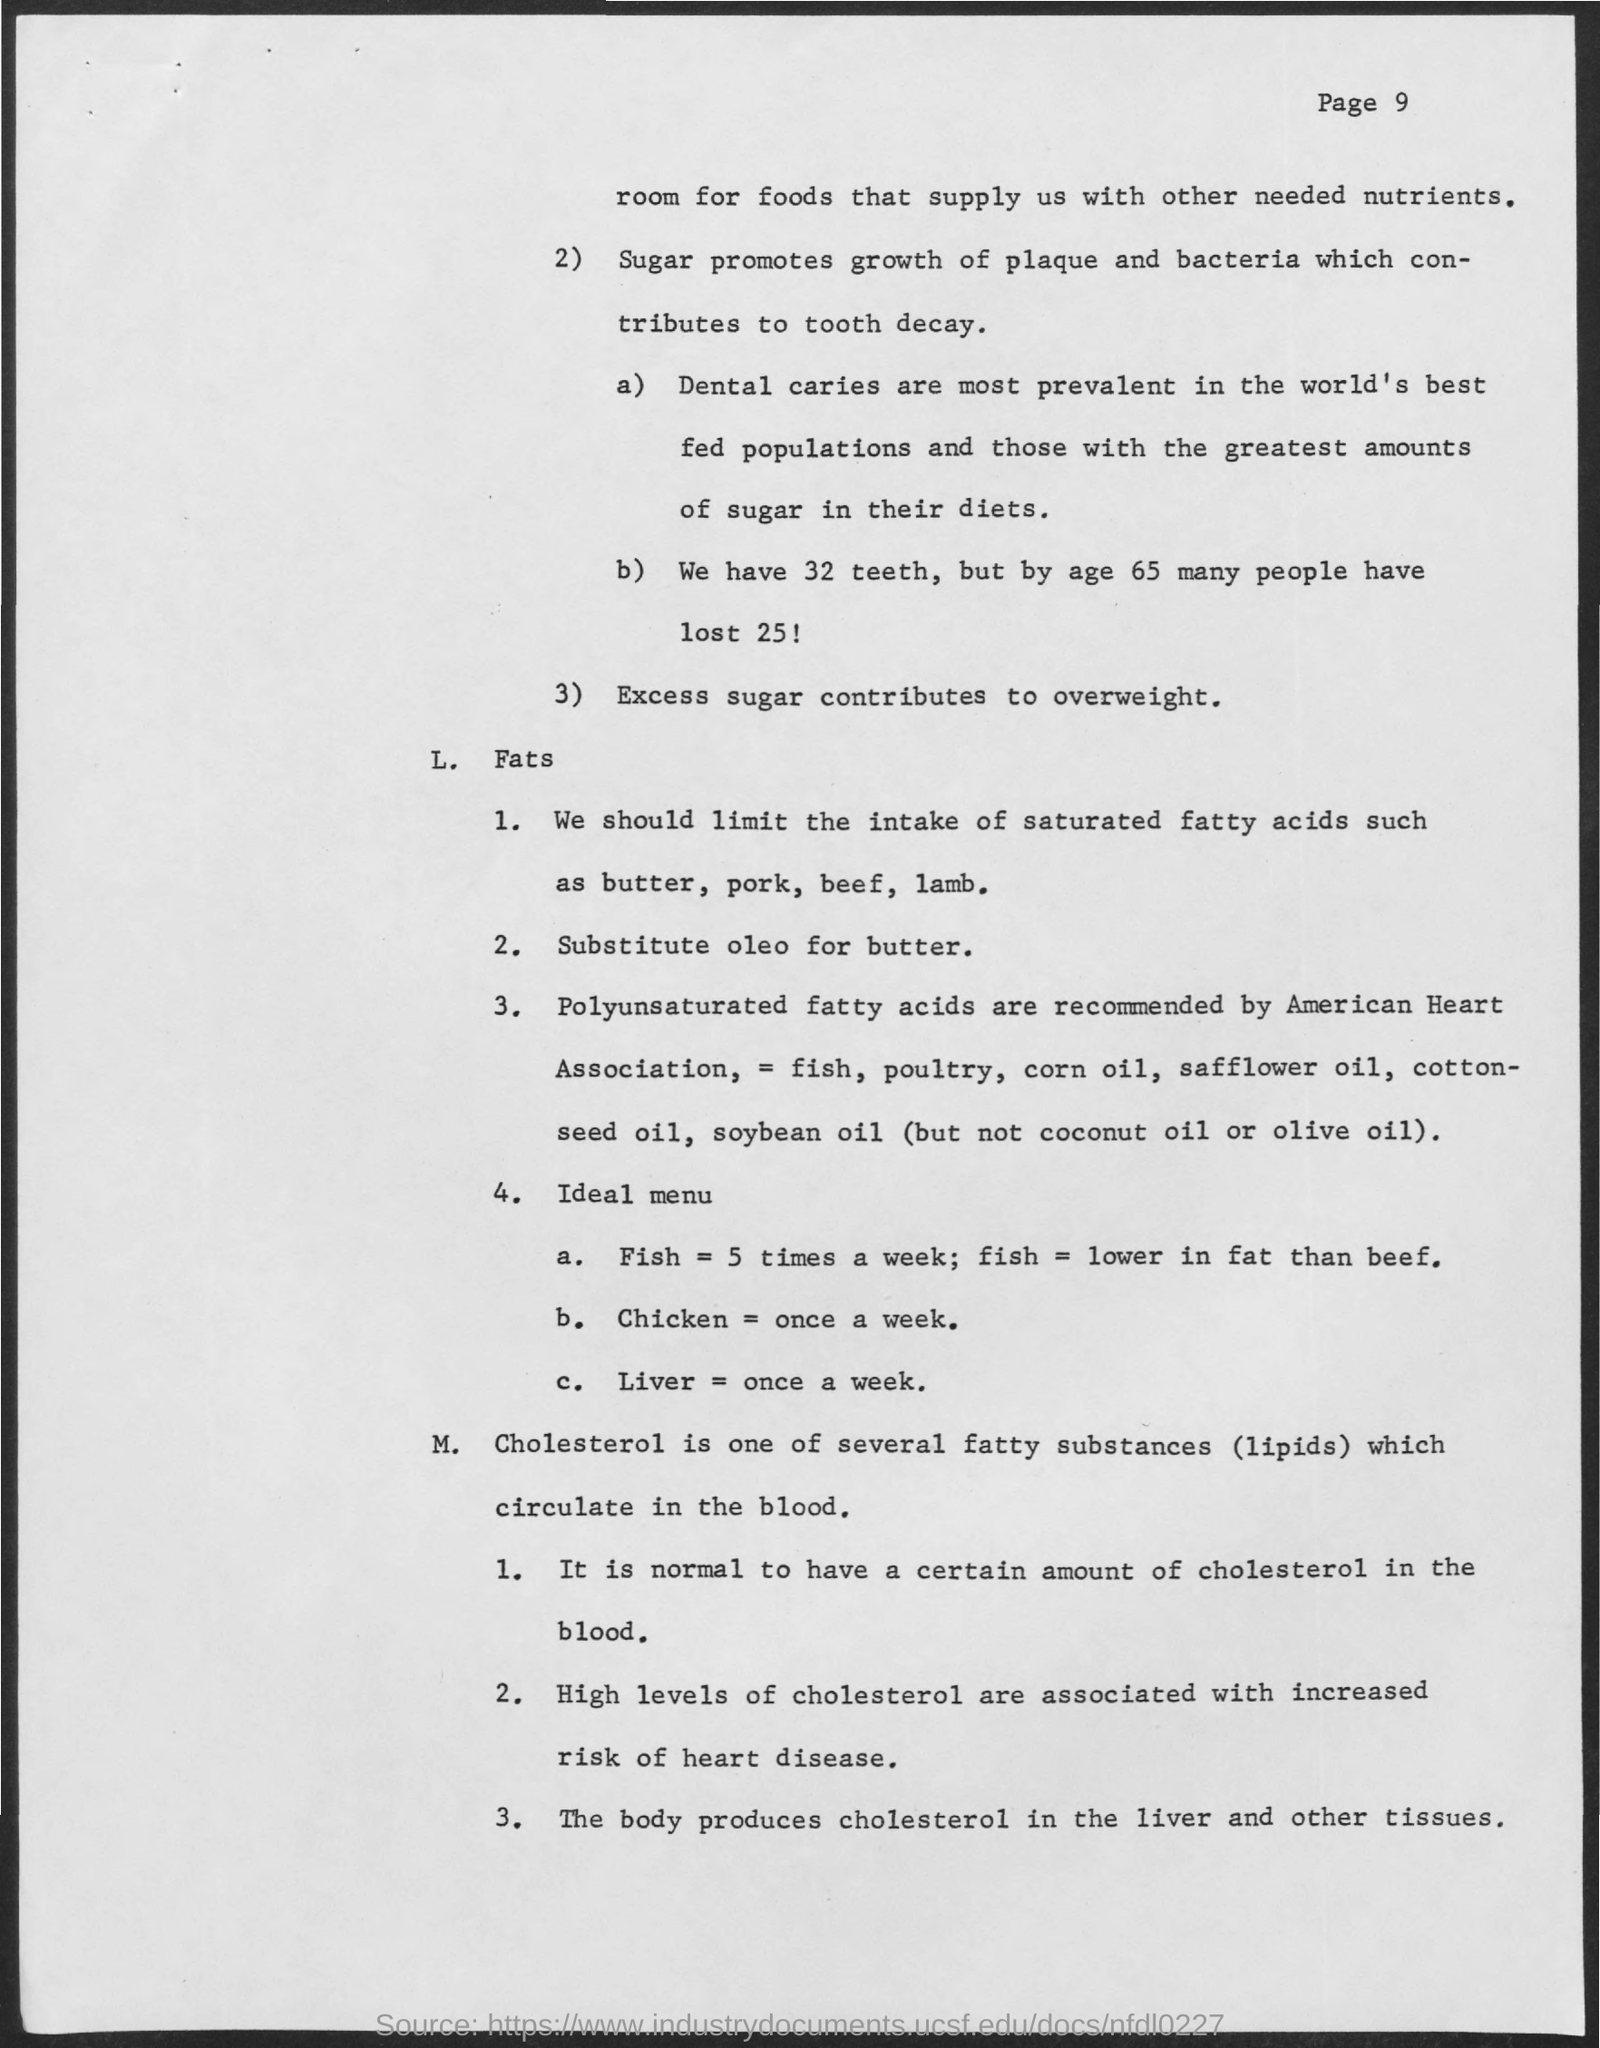What promotes the growth of plaque and bacteria which contributes to tooth decay?
Your answer should be very brief. Sugar. Which is one of the several fatty substances  (lipids) which circulate in blood?
Offer a very short reply. CHOLESTEROL. 